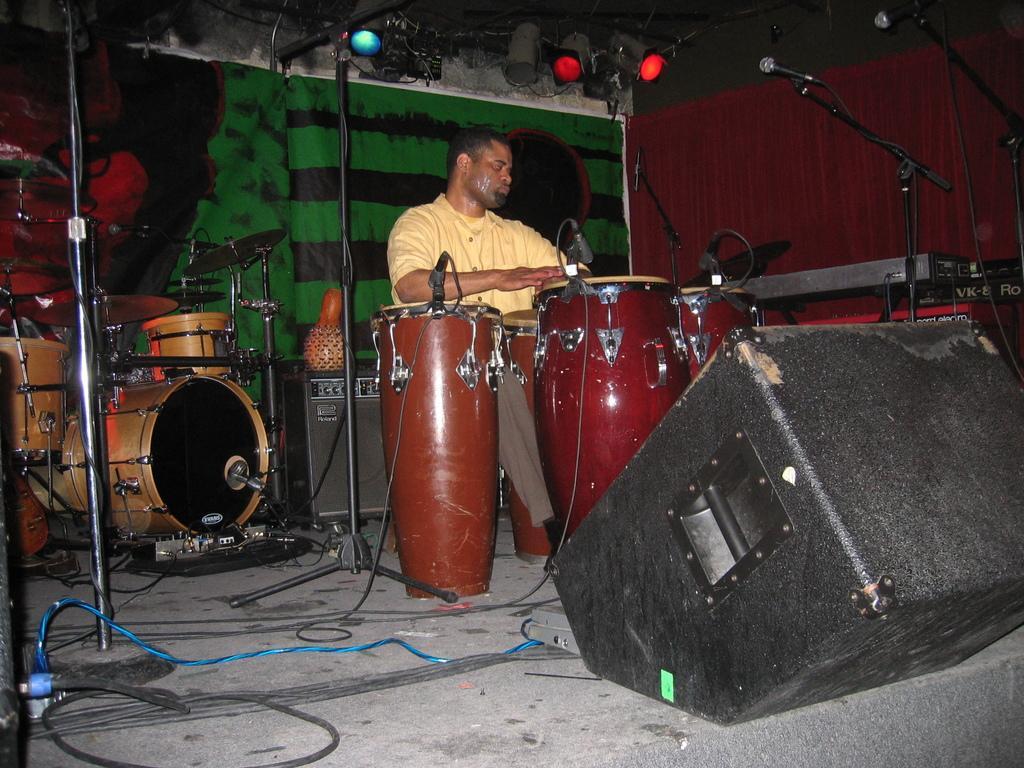In one or two sentences, can you explain what this image depicts? In this image I see a man who is sitting near to the drums and there are mics over here. In the background I see another musical instrument, lights and and an equipment over here and I see the wires. 